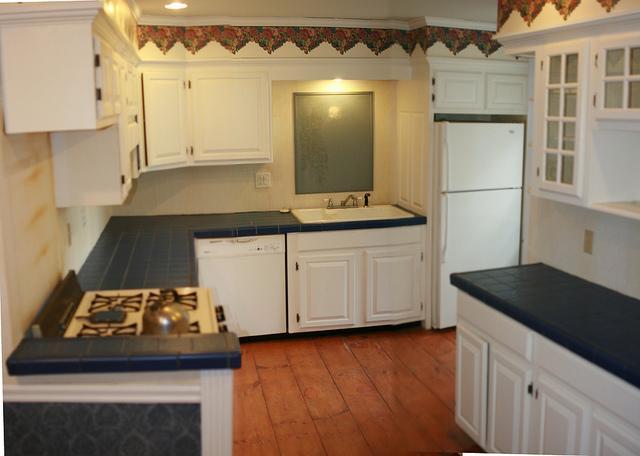How many sinks are there?
Give a very brief answer. 1. How many forks are there?
Give a very brief answer. 0. 